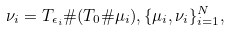<formula> <loc_0><loc_0><loc_500><loc_500>{ } \nu _ { i } = T _ { \epsilon _ { i } } \# ( T _ { 0 } \# \mu _ { i } ) , \{ \mu _ { i } , \nu _ { i } \} _ { i = 1 } ^ { N } ,</formula> 